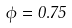<formula> <loc_0><loc_0><loc_500><loc_500>\phi = 0 . 7 5</formula> 